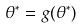<formula> <loc_0><loc_0><loc_500><loc_500>\theta ^ { * } = g ( \theta ^ { * } )</formula> 